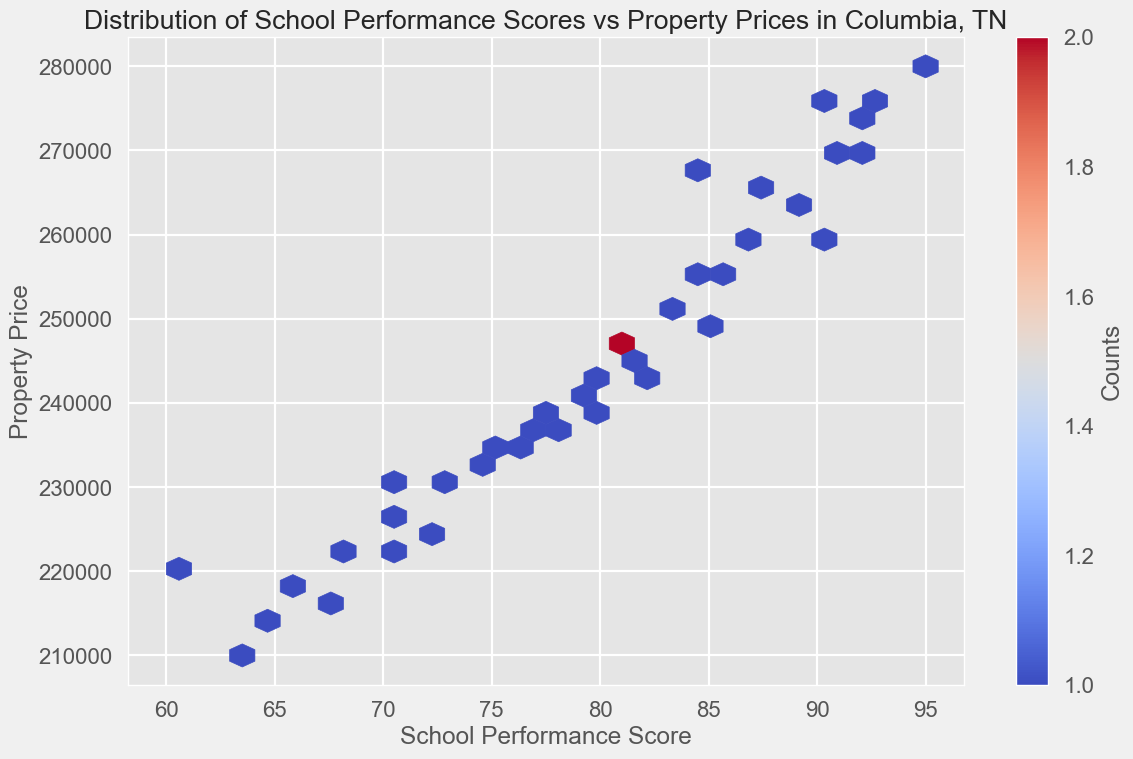What is the general trend between school performance scores and property prices? Observing the hexbin plot, it appears that higher school performance scores generally correlate with higher property prices. This can be interpreted by looking at the denser regions towards the upper right of the plot.
Answer: Positive correlation Do higher school performance scores lead to higher property prices in Columbia, TN? The hexbin plot shows a noticeable concentration of data points where higher school performance scores correspond to higher property prices, indicating a positive relationship between the two variables.
Answer: Yes How are property prices distributed when school performance scores are between 70 and 80? To answer this, look at the density of hexagons (color intensity) in the range of 70 to 80 on the x-axis (school performance score). There are various property prices in this range, but the distribution seems to cluster around $230,000 to $240,000.
Answer: Around $230,000 to $240,000 Between what ranges of school performance scores do property prices show the highest concentration? The densest regions where the hexagons are most intense are between school performance scores of approximately 80 to 90.
Answer: 80 to 90 What is the most frequent property price range when the school performance score is above 85? Observing the hexbin color density, the most frequent property price range when the school performance score is above 85 seems to be between $260,000 and $280,000.
Answer: $260,000 to $280,000 Are there any school performance scores that show a wide range of property prices? Yes, school performance scores around 80 show a wide range of property prices from approximately $240,000 to $270,000, indicating variability in property prices for that score.
Answer: Yes, around 80 Which has a stronger concentration of higher property prices, school performance scores above the median or below the median? The median school performance score can be calculated to be around 80 (since the dataset is ordered). Observing the heatmap, higher property prices are more concentrated with school performance scores above 80.
Answer: Above the median Is there any significant drop in property prices for lower school performance scores? Examining the hexbin plot, you can see that for school performance scores below 70, the property prices significantly drop, mostly staying below $230,000.
Answer: Yes Which price range of properties is most common when the school performance score is above 90? The hexbin plot shows the highest color intensity in the price range of $270,000 to $280,000 when school performance scores are above 90, indicating this price range is most common.
Answer: $270,000 to $280,000 In what way can this visual representation of the data help a prospective homebuyer make a decision? The hexbin plot visually demonstrates that higher school performance scores are associated with higher property prices. This can help prospective homebuyers prioritize school performance as a factor when assessing property values in different areas.
Answer: It shows the impact of school performance on property prices, useful for homebuying decisions 